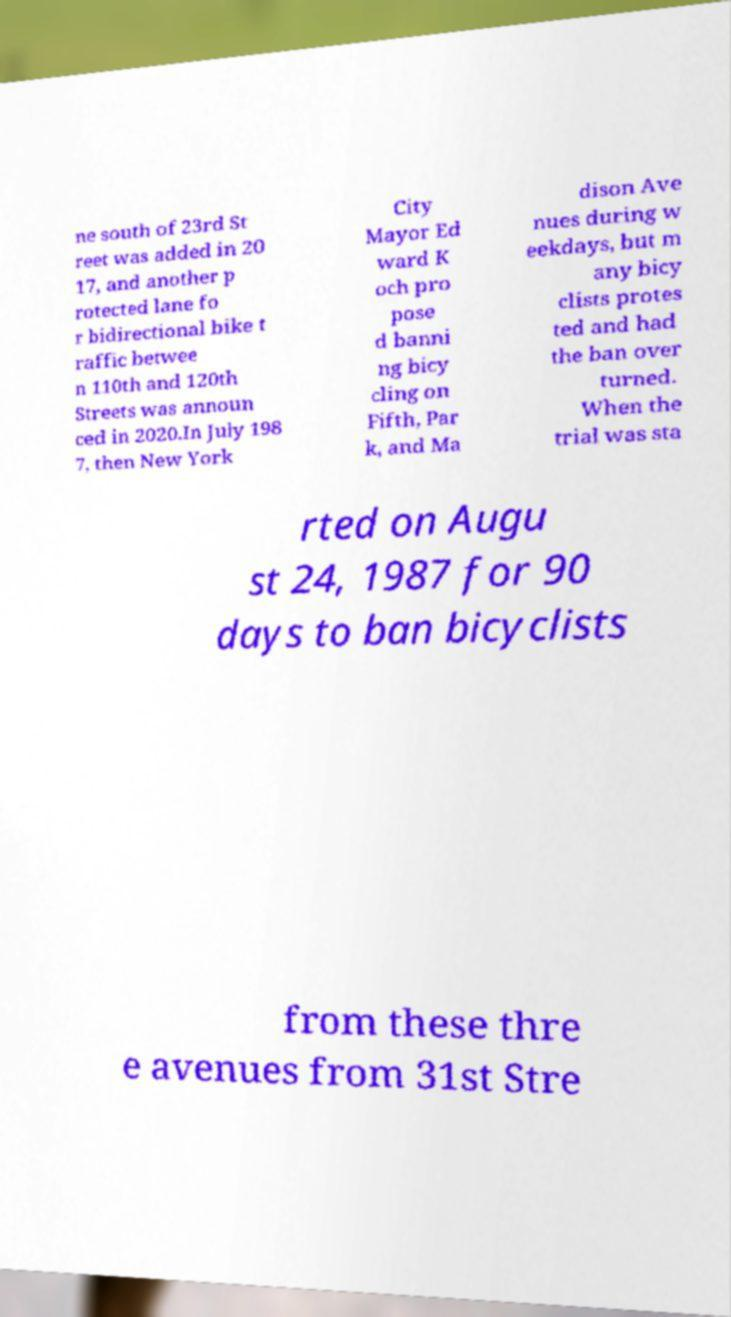Please identify and transcribe the text found in this image. ne south of 23rd St reet was added in 20 17, and another p rotected lane fo r bidirectional bike t raffic betwee n 110th and 120th Streets was announ ced in 2020.In July 198 7, then New York City Mayor Ed ward K och pro pose d banni ng bicy cling on Fifth, Par k, and Ma dison Ave nues during w eekdays, but m any bicy clists protes ted and had the ban over turned. When the trial was sta rted on Augu st 24, 1987 for 90 days to ban bicyclists from these thre e avenues from 31st Stre 